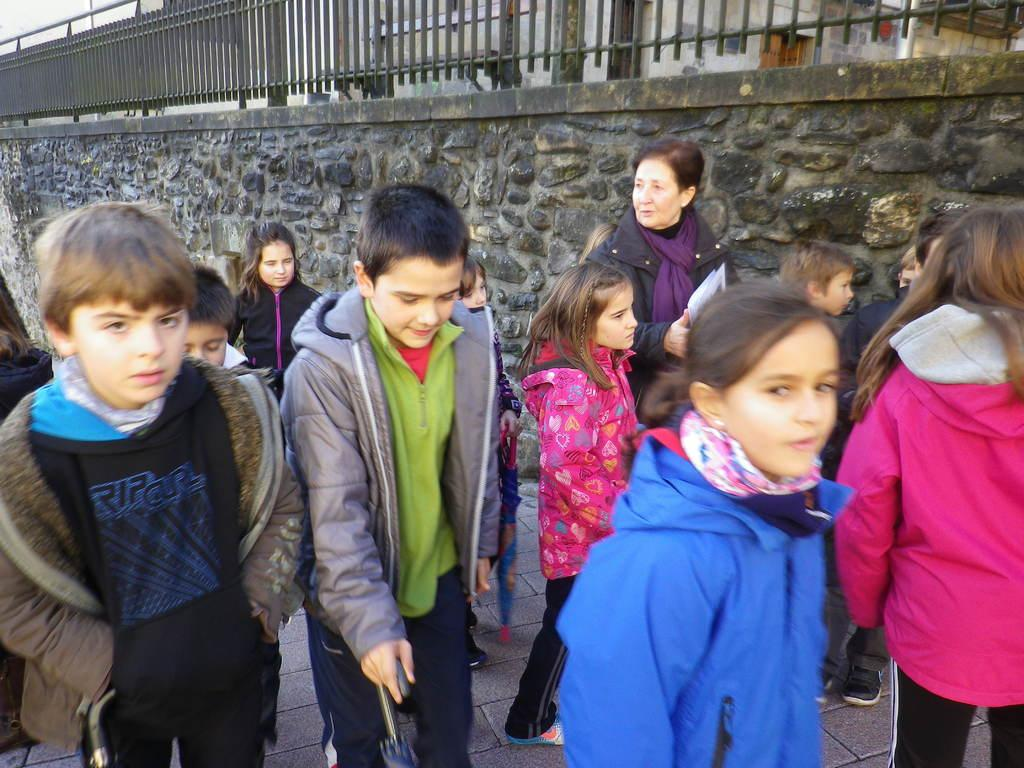What is happening in the image involving the groups of people? There are groups of people standing in the image. What can be seen in the background of the image? There is a wall and a building visible in the image. What type of barrier is present in the image? There are black barricades in the image. Is there a game being played in the image involving a stream? There is no game or stream present in the image. 